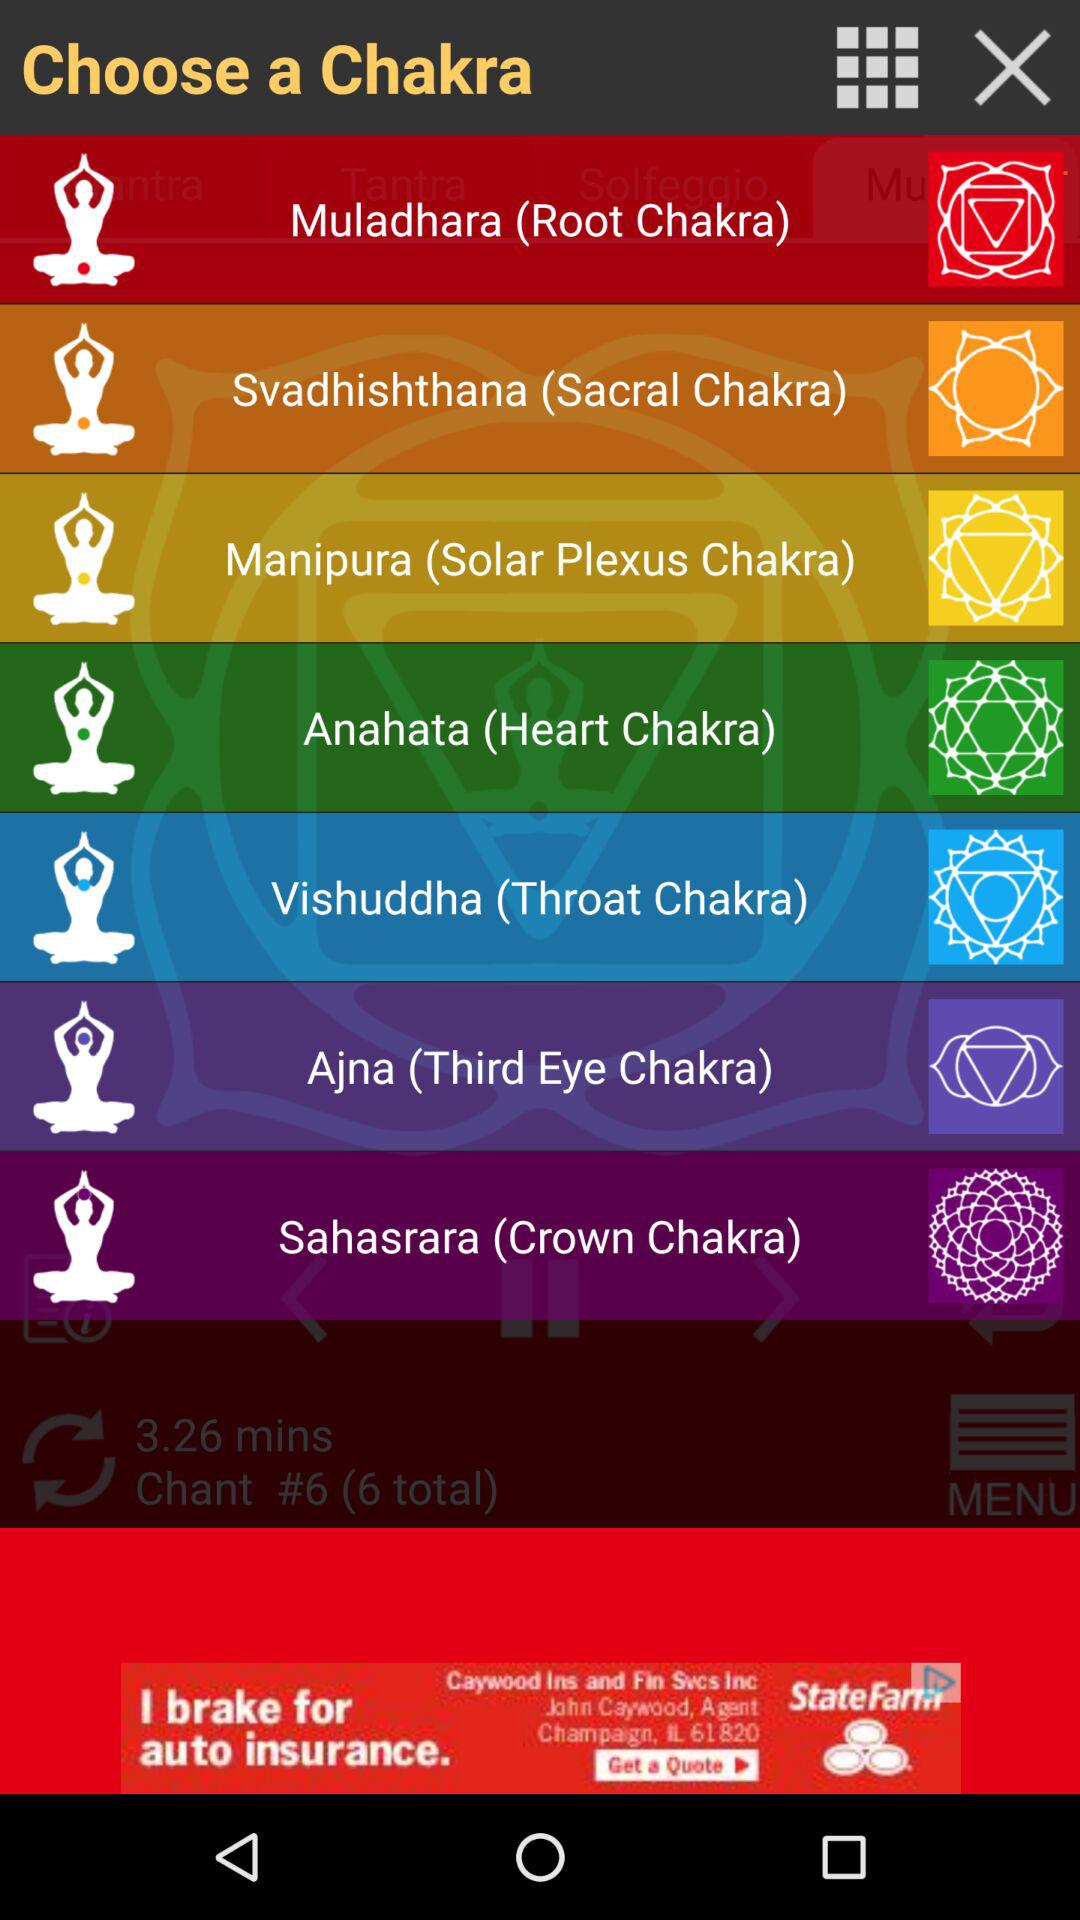How many chakras are there?
Answer the question using a single word or phrase. 7 